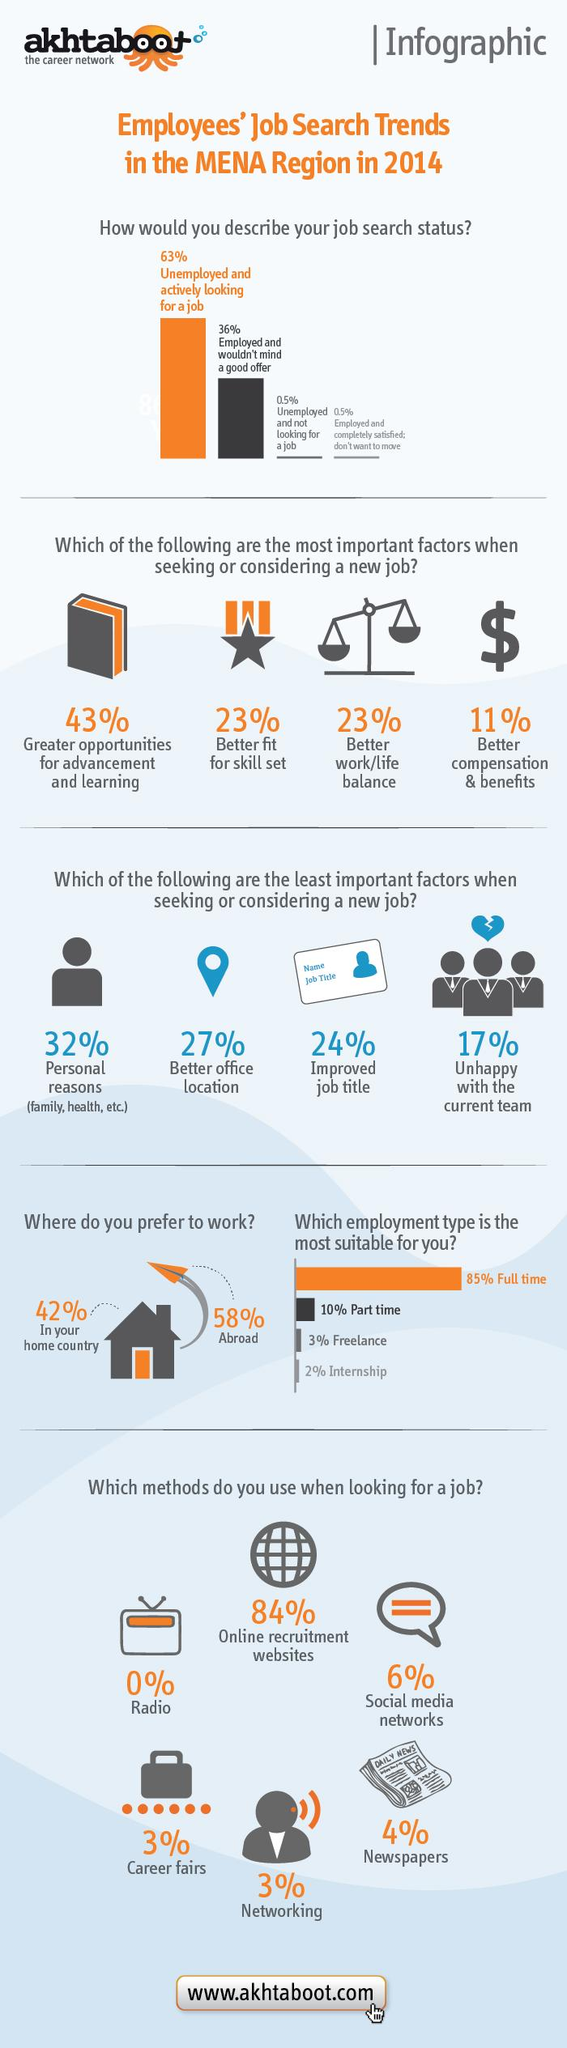Give some essential details in this illustration. According to a survey, 58% of people prefer to work outside their home country. When considering a new job, the presence of the $ sign indicates a focus on better compensation and benefits. It is never used when looking for a job: radio. When considering a new job, 23% of people prioritize finding a better work-life balance. The percentage of individuals who are unemployed and not looking for a job, as well as those who are employed and completely satisfied with their current situation, with no intention of moving, is 1%. 